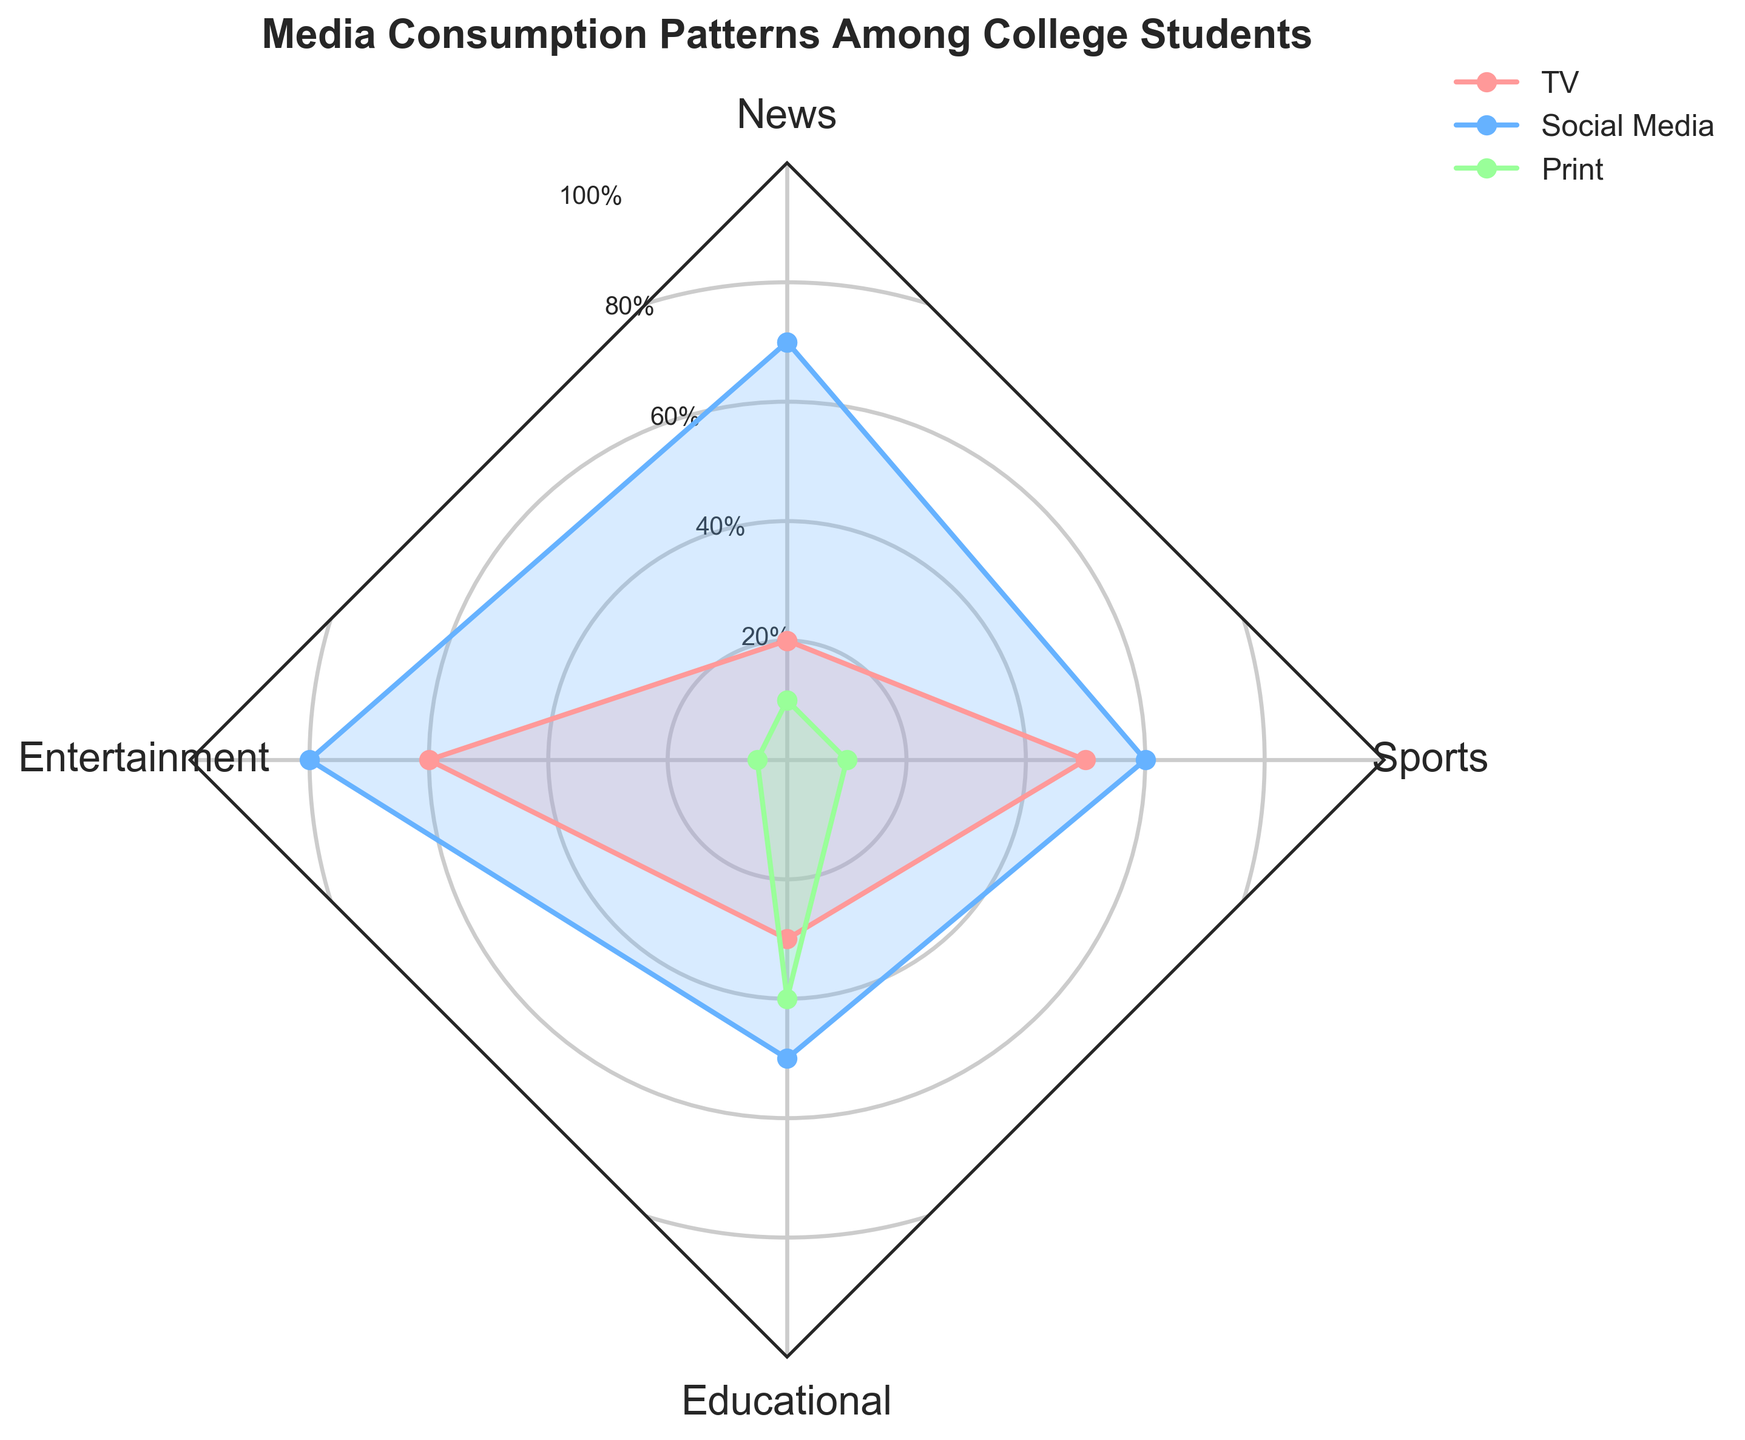What is the title of the radar chart? The title of the radar chart is typically displayed at the top and is often set off from the rest of the chart to make it easy to find.
Answer: Media Consumption Patterns Among College Students How many categories are there in the radar chart? By looking at the axes labels, identify the distinct groups of data present. In this case, the groups are labeled around the perimeter.
Answer: Four Which media type shows the highest consumption for 'Entertainment'? To determine this, locate the 'Entertainment' category on the radar chart and assess the values for TV, Social Media, and Print.
Answer: Social Media Compare the 'Print' consumption values for 'News' and 'Educational'. Which one is higher? Locate the 'News' and 'Educational' categories and then check the corresponding values for 'Print'. Compare these values directly.
Answer: Educational What's the average 'TV' consumption value across all categories? Add together the 'TV' values for all categories and divide by the total number of categories. The values are: 20, 60, 30, and 50. Sum = 160. 160 divided by 4 = 40.
Answer: 40 Which media type shows the lowest consumption for 'Sports'? Locate the 'Sports' category on the radar chart and compare the values for TV, Social Media, and Print. The lowest value indicates the least consumption.
Answer: Print What is the total 'Social Media' consumption value for all categories combined? Add up all the 'Social Media' values for each category. The values are 70, 80, 50, and 60. Sum = 260.
Answer: 260 Is the 'Educational' value higher for 'Print' or 'Social Media'? Locate the 'Educational' category and compare the values corresponding to 'Print' and 'Social Media'.
Answer: Print Which category shows the most equal distribution among all three media types? This requires visual inspection of the sections for each category to see which has the most similar values for TV, Social Media, and Print.
Answer: Educational Between 'News' and 'Sports', which category has a higher 'TV' consumption value? Locate the 'News' and 'Sports' categories, check the 'TV' values for each, and compare them.
Answer: Sports 